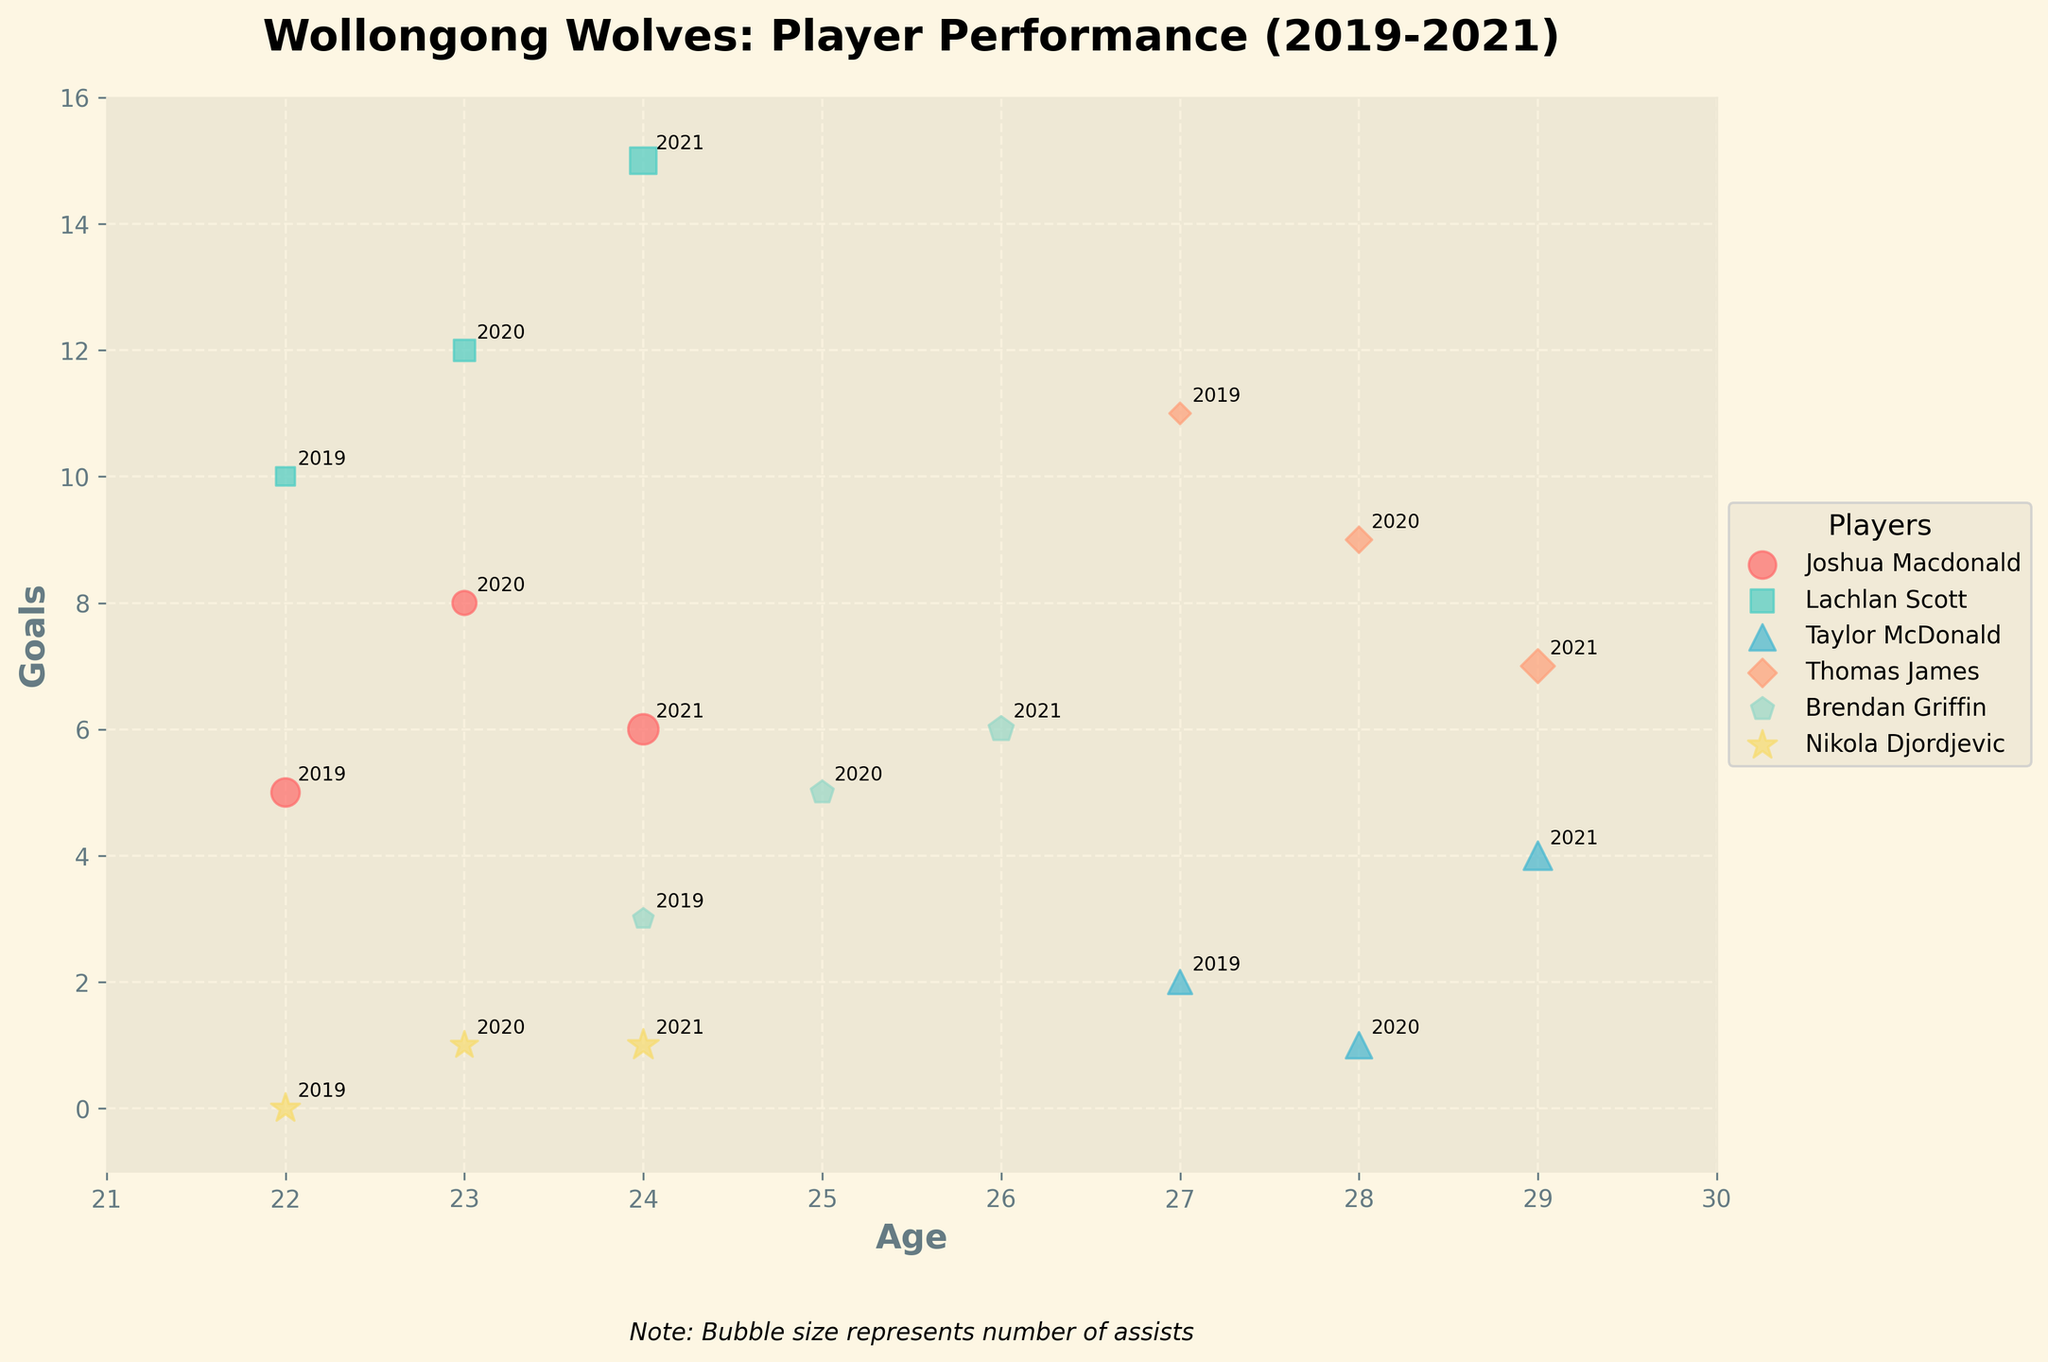what is the title of the plot? The title of the plot is typically displayed at the top of the chart. It gives a summary or main topic of the data being visualized. Here, the title clearly displays the focus on Wollongong Wolves player performance between 2019 and 2021.
Answer: Wollongong Wolves: Player Performance (2019-2021) Which player had the most goals at the age of 24? Look at the scatter plot and focus on the points at the age of 24. Compare the goals denoted by the y-axis.
Answer: Lachlan Scott What's the average age of players in the 2020 season? To find the average age for the 2020 season, list all player's ages for that season and calculate the mean ((23+23+28+28+25+23)/6).
Answer: 25 Which player had the least assists at age 28? Locate the points plotted at age 28 and compare the size of the bubbles (which represent assists). The smallest bubble indicates the fewest assists.
Answer: Thomas James What is the overall trend for Lachlan Scott's goals over the seasons? Identify Lachlan Scott's points for each season by his marker and color. Note the values on the y-axis for each season to identify the trend. In Lachlan Scott's case, notice whether his goals increase, decrease, or stay the same over the seasons.
Answer: Increasing Which season did Taylor McDonald have the highest assists? Find Taylor McDonald’s points for each season and compare the sizes of the bubbles which represent the assists. The largest bubble indicates the highest assists.
Answer: 2021 Who had more goals in 2019: Joshua Macdonald or Brendan Griffin? Look at the goals on the y-axis for each player in the 2019 season. Compare them directly.
Answer: Joshua Macdonald How many players are plotted in the scatter plot? Count the unique players represented in the legend of the scatter plot.
Answer: 6 What is the age range of the players analyzed in the plot? Look at the scatter plot and identify the minimum and maximum values on the x-axis (Age). Subtract the smallest value from the largest.
Answer: 21 to 29 